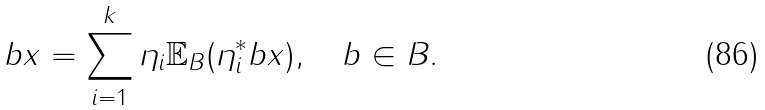<formula> <loc_0><loc_0><loc_500><loc_500>b x = \sum _ { i = 1 } ^ { k } \eta _ { i } { \mathbb { E } } _ { B } ( \eta _ { i } ^ { * } b x ) , \quad b \in B .</formula> 